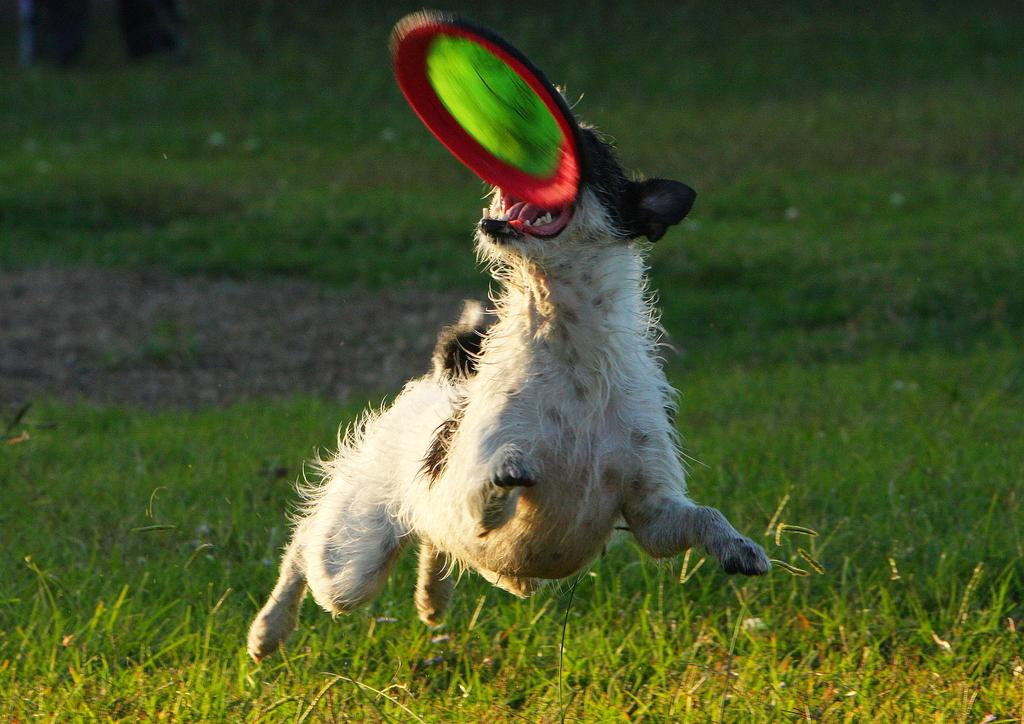What animal is present in the image? There is a dog in the image. What is the dog doing in the image? The dog is jumping in the image. What object is in the air in the image? There is a frisbee in the air in the image. What is the dog trying to catch in the image? The dog appears to be jumping to catch the frisbee in the image. What type of surface is on the ground in the image? There is grass on the ground in the image. What type of brake can be seen on the dog in the image? There is no brake present on the dog in the image; it is a living animal and does not have brakes. 